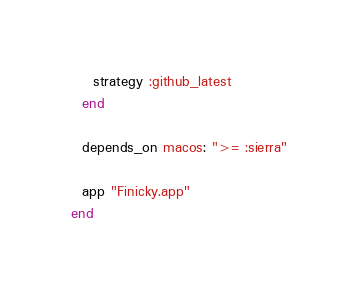Convert code to text. <code><loc_0><loc_0><loc_500><loc_500><_Ruby_>    strategy :github_latest
  end

  depends_on macos: ">= :sierra"

  app "Finicky.app"
end
</code> 